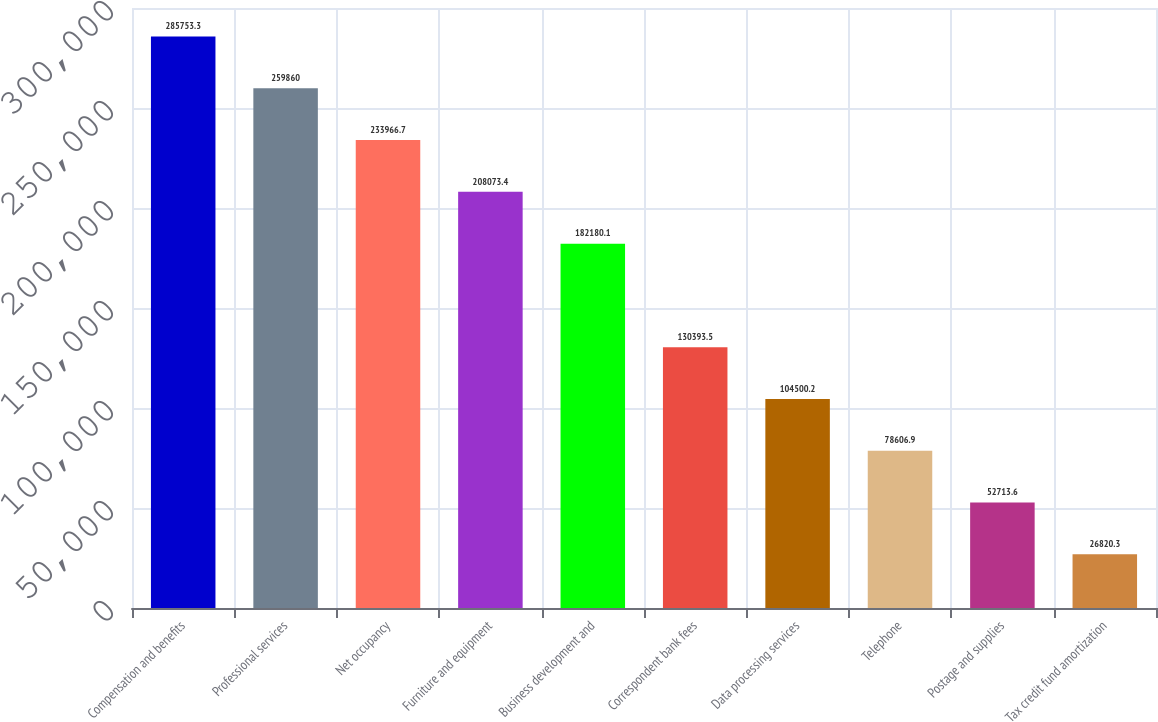Convert chart to OTSL. <chart><loc_0><loc_0><loc_500><loc_500><bar_chart><fcel>Compensation and benefits<fcel>Professional services<fcel>Net occupancy<fcel>Furniture and equipment<fcel>Business development and<fcel>Correspondent bank fees<fcel>Data processing services<fcel>Telephone<fcel>Postage and supplies<fcel>Tax credit fund amortization<nl><fcel>285753<fcel>259860<fcel>233967<fcel>208073<fcel>182180<fcel>130394<fcel>104500<fcel>78606.9<fcel>52713.6<fcel>26820.3<nl></chart> 